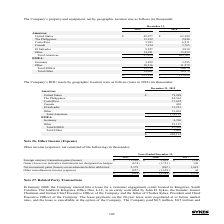According to Sykes Enterprises Incorporated's financial document, What was the Other miscellaneous income (expense) in 2019? According to the financial document, (857) (in thousands). The relevant text states: "Other miscellaneous income (expense) (857) (1,659) 44..." Also, What was the Net investment gains (losses) on investments held in rabbi trust in 2017? According to the financial document, 1,619 (in thousands). The relevant text states: "s) on investments held in rabbi trust 2,379 (867) 1,619..." Also, Which years was Other income (expense), net calculated? The document contains multiple relevant values: 2019, 2018, 2017. From the document: "2019 2018 2017 2019 2018 2017 2019 2018 2017..." Also, In how many years was Other income, net a negative value? Counting the relevant items in the document: 2019, 2018, I find 2 instances. The key data points involved are: 2018, 2019. Also, can you calculate: What was the overall change in Net investment gains  on investments held in rabbi trust in 2019 from 2017? Based on the calculation: 2,379-1,619, the result is 760 (in thousands). This is based on the information: "s) on investments held in rabbi trust 2,379 (867) 1,619 gains (losses) on investments held in rabbi trust 2,379 (867) 1,619..." The key data points involved are: 1,619, 2,379. Also, can you calculate: What was the overall percentage change in Net investment gains  on investments held in rabbi trust in 2019 from 2017? To answer this question, I need to perform calculations using the financial data. The calculation is: (2,379-1,619)/1,619, which equals 46.94 (percentage). This is based on the information: "s) on investments held in rabbi trust 2,379 (867) 1,619 gains (losses) on investments held in rabbi trust 2,379 (867) 1,619..." The key data points involved are: 1,619, 2,379. 